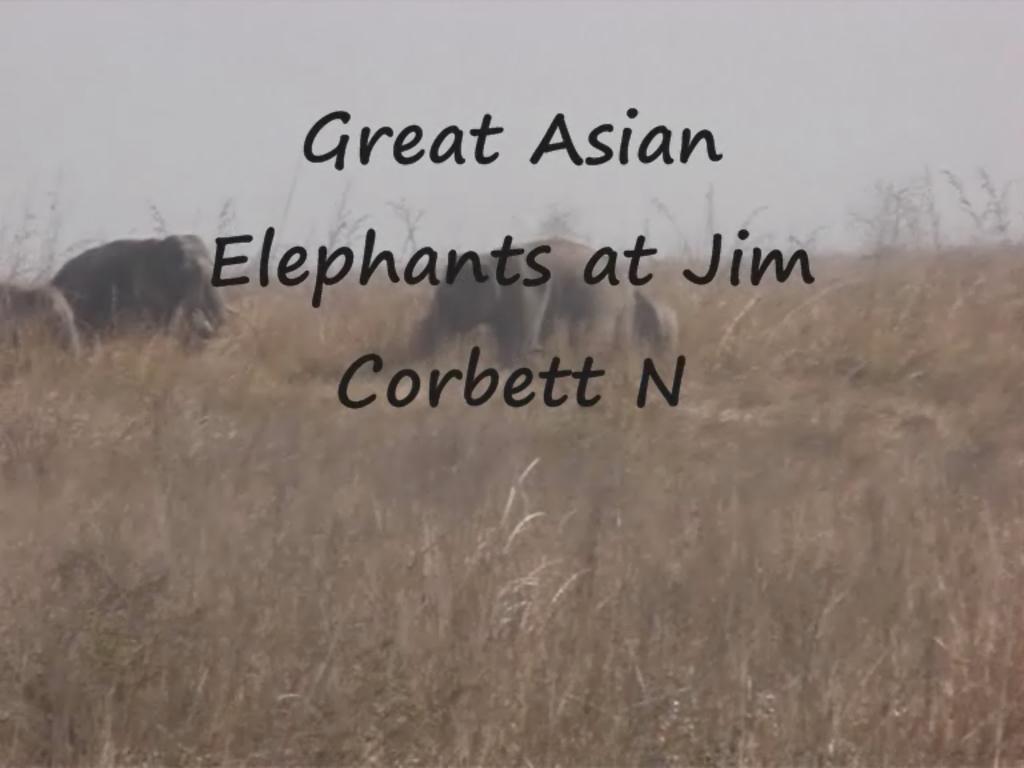Describe this image in one or two sentences. In this image there are elephants walking, there is grass, and in the background there is sky and there are watermarks on the image. 